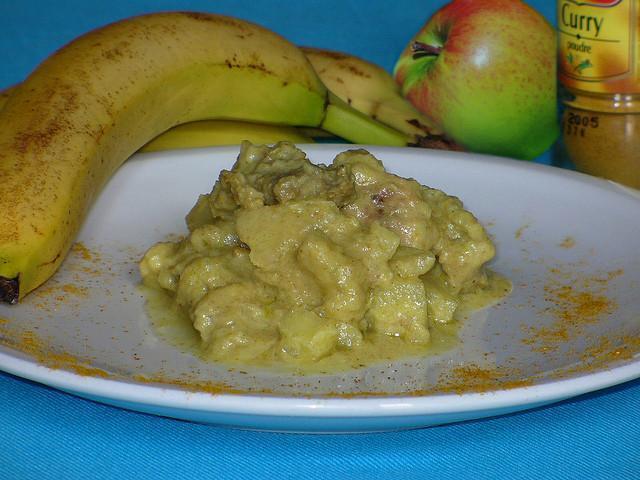How many different types of fruit are in the picture?
Give a very brief answer. 2. 